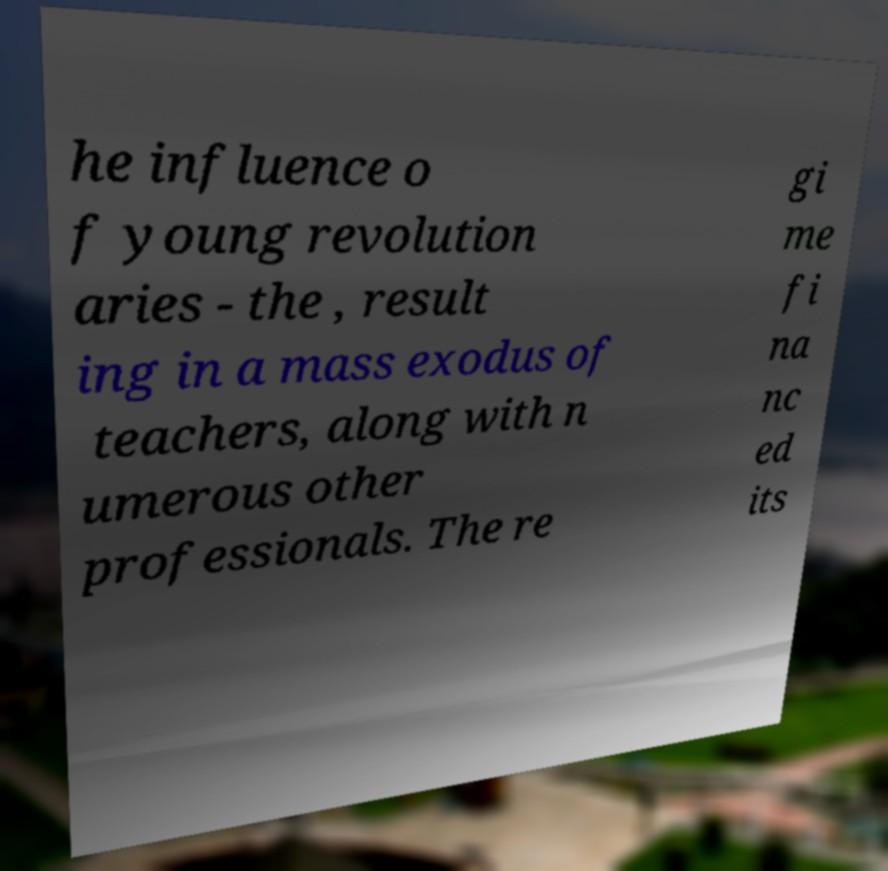Can you read and provide the text displayed in the image?This photo seems to have some interesting text. Can you extract and type it out for me? he influence o f young revolution aries - the , result ing in a mass exodus of teachers, along with n umerous other professionals. The re gi me fi na nc ed its 